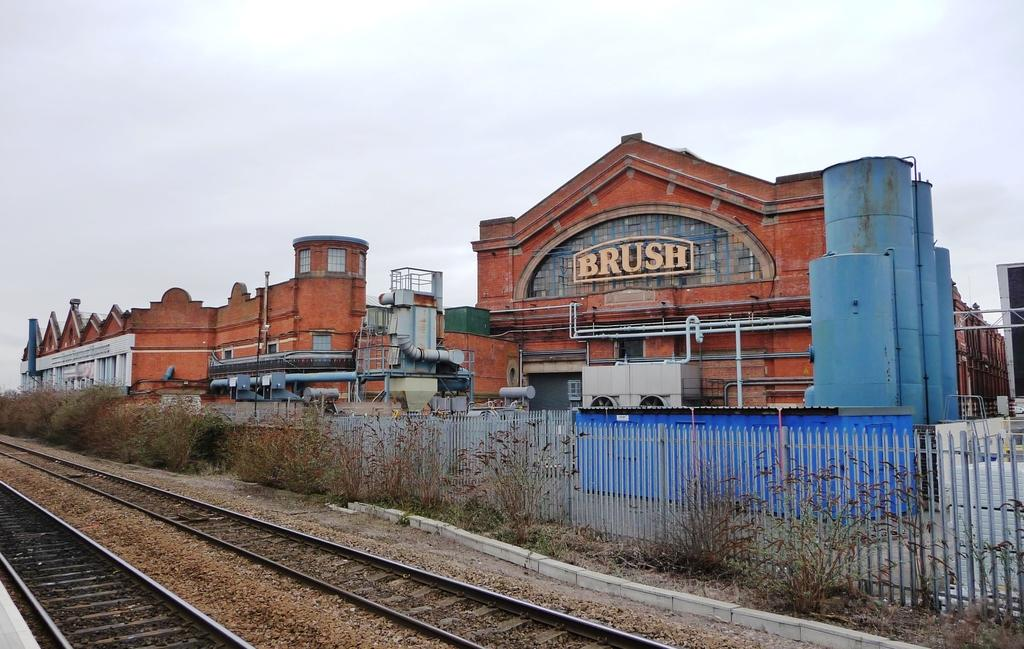What type of pathway is present in the image? There is a track in the image. What structures can be seen in the image? Buildings and houses are visible in the image. What type of barrier is present in the image? There is fencing in the image. What type of vegetation is present in the image? Plants are present in the image. What type of scarf is the governor wearing in the image? There is no governor or scarf present in the image. How many babies are visible in the image? There are no babies present in the image. 